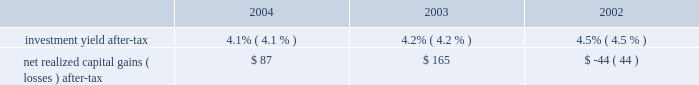Has decreased during the period from 2002 to 2004 , principally due to the increase in earned premium and due to cost containment measures undertaken by management .
In business insurance and personal lines , the expense ratio is expected to decrease further in 2005 , largely as a result of expected increases in earned premium .
In specialty commercial , the expense ratio is expected to increase slightly in 2005 due to changes in the business mix , most notably the company 2019s decision in the fourth quarter of 2004 to exit the multi-peril crop insurance program which will eliminate significant expense reimbursements from the specialty commercial segment .
Policyholder dividend ratio : the policyholder dividend ratio is the ratio of policyholder dividends to earned premium .
Combined ratio : the combined ratio is the sum of the loss and loss adjustment expense ratio , the expense ratio and the policyholder dividend ratio .
This ratio is a relative measurement that describes the related cost of losses and expense for every $ 100 of earned premiums .
A combined ratio below 100.0 demonstrates underwriting profit ; a combined ratio above 100.0 demonstrates underwriting losses .
The combined ratio has decreased from 2003 to 2004 primarily because of improvement in the expense ratio .
The combined ratio in 2005 could be significantly higher or lower than the 2004 combined ratio depending on the level of catastrophe losses , but will also be impacted by changes in pricing and an expected moderation in favorable loss cost trends .
Catastrophe ratio : the catastrophe ratio ( a component of the loss and loss adjustment expense ratio ) represents the ratio of catastrophe losses ( net of reinsurance ) to earned premiums .
A catastrophe is an event that causes $ 25 or more in industry insured property losses and affects a significant number of property and casualty policyholders and insurers .
By their nature , catastrophe losses vary dramatically from year to year .
Based on the mix and geographic dispersion of premium written and estimates derived from various catastrophe loss models , the company 2019s expected catastrophe ratio over the long-term is 3.0 points .
Before considering the reduction in ongoing operation 2019s catastrophe reserves related to september 11 of $ 298 in 2004 , the catastrophe ratio in 2004 was 5.3 points .
See 201crisk management strategy 201d below for a discussion of the company 2019s property catastrophe risk management program that serves to mitigate the company 2019s net exposure to catastrophe losses .
Combined ratio before catastrophes and prior accident year development : the combined ratio before catastrophes and prior accident year development represents the combined ratio for the current accident year , excluding the impact of catastrophes .
The company believes this ratio is an important measure of the trend in profitability since it removes the impact of volatile and unpredictable catastrophe losses and prior accident year reserve development .
Before considering catastrophes , the combined ratio related to current accident year business has improved from 2002 to 2004 principally due to earned pricing increases and favorable claim frequency .
Other operations underwriting results : the other operations segment is responsible for managing operations of the hartford that have discontinued writing new or renewal business as well as managing the claims related to asbestos and environmental exposures .
As such , neither earned premiums nor underwriting ratios are meaningful financial measures .
Instead , management believes that underwriting result is a more meaningful measure .
The net underwriting loss for 2002 through 2004 is primarily due to prior accident year loss development , including $ 2.6 billion of net asbestos reserve strengthening in 2003 .
Reserve estimates within other operations , including estimates for asbestos and environmental claims , are inherently uncertain .
Refer to the other operations segment md&a for further discussion of other operation's underwriting results .
Total property & casualty investment earnings .
The investment return , or yield , on property & casualty 2019s invested assets is an important element of the company 2019s earnings since insurance products are priced with the assumption that premiums received can be invested for a period of time before loss and loss adjustment expenses are paid .
For longer tail lines , such as workers 2019 compensation and general liability , claims are paid over several years and , therefore , the premiums received for these lines of business can generate significant investment income .
Him determines the appropriate allocation of investments by asset class and measures the investment yield performance for each asset class against market indices or other benchmarks .
Due to the emphasis on preservation of capital and the need to maintain sufficient liquidity to satisfy claim obligations , the vast majority of property and casualty 2019s invested assets have been held in fixed maturities , including , among other asset classes , corporate bonds , municipal bonds , government debt , short-term debt , mortgage- .
What is the total net realized gain for the last three years? 
Computations: ((87 + 165) - 44)
Answer: 208.0. Has decreased during the period from 2002 to 2004 , principally due to the increase in earned premium and due to cost containment measures undertaken by management .
In business insurance and personal lines , the expense ratio is expected to decrease further in 2005 , largely as a result of expected increases in earned premium .
In specialty commercial , the expense ratio is expected to increase slightly in 2005 due to changes in the business mix , most notably the company 2019s decision in the fourth quarter of 2004 to exit the multi-peril crop insurance program which will eliminate significant expense reimbursements from the specialty commercial segment .
Policyholder dividend ratio : the policyholder dividend ratio is the ratio of policyholder dividends to earned premium .
Combined ratio : the combined ratio is the sum of the loss and loss adjustment expense ratio , the expense ratio and the policyholder dividend ratio .
This ratio is a relative measurement that describes the related cost of losses and expense for every $ 100 of earned premiums .
A combined ratio below 100.0 demonstrates underwriting profit ; a combined ratio above 100.0 demonstrates underwriting losses .
The combined ratio has decreased from 2003 to 2004 primarily because of improvement in the expense ratio .
The combined ratio in 2005 could be significantly higher or lower than the 2004 combined ratio depending on the level of catastrophe losses , but will also be impacted by changes in pricing and an expected moderation in favorable loss cost trends .
Catastrophe ratio : the catastrophe ratio ( a component of the loss and loss adjustment expense ratio ) represents the ratio of catastrophe losses ( net of reinsurance ) to earned premiums .
A catastrophe is an event that causes $ 25 or more in industry insured property losses and affects a significant number of property and casualty policyholders and insurers .
By their nature , catastrophe losses vary dramatically from year to year .
Based on the mix and geographic dispersion of premium written and estimates derived from various catastrophe loss models , the company 2019s expected catastrophe ratio over the long-term is 3.0 points .
Before considering the reduction in ongoing operation 2019s catastrophe reserves related to september 11 of $ 298 in 2004 , the catastrophe ratio in 2004 was 5.3 points .
See 201crisk management strategy 201d below for a discussion of the company 2019s property catastrophe risk management program that serves to mitigate the company 2019s net exposure to catastrophe losses .
Combined ratio before catastrophes and prior accident year development : the combined ratio before catastrophes and prior accident year development represents the combined ratio for the current accident year , excluding the impact of catastrophes .
The company believes this ratio is an important measure of the trend in profitability since it removes the impact of volatile and unpredictable catastrophe losses and prior accident year reserve development .
Before considering catastrophes , the combined ratio related to current accident year business has improved from 2002 to 2004 principally due to earned pricing increases and favorable claim frequency .
Other operations underwriting results : the other operations segment is responsible for managing operations of the hartford that have discontinued writing new or renewal business as well as managing the claims related to asbestos and environmental exposures .
As such , neither earned premiums nor underwriting ratios are meaningful financial measures .
Instead , management believes that underwriting result is a more meaningful measure .
The net underwriting loss for 2002 through 2004 is primarily due to prior accident year loss development , including $ 2.6 billion of net asbestos reserve strengthening in 2003 .
Reserve estimates within other operations , including estimates for asbestos and environmental claims , are inherently uncertain .
Refer to the other operations segment md&a for further discussion of other operation's underwriting results .
Total property & casualty investment earnings .
The investment return , or yield , on property & casualty 2019s invested assets is an important element of the company 2019s earnings since insurance products are priced with the assumption that premiums received can be invested for a period of time before loss and loss adjustment expenses are paid .
For longer tail lines , such as workers 2019 compensation and general liability , claims are paid over several years and , therefore , the premiums received for these lines of business can generate significant investment income .
Him determines the appropriate allocation of investments by asset class and measures the investment yield performance for each asset class against market indices or other benchmarks .
Due to the emphasis on preservation of capital and the need to maintain sufficient liquidity to satisfy claim obligations , the vast majority of property and casualty 2019s invested assets have been held in fixed maturities , including , among other asset classes , corporate bonds , municipal bonds , government debt , short-term debt , mortgage- .
What is the total value of the investment in 2004? 
Computations: (87 / 4.1%)
Answer: 2121.95122. 